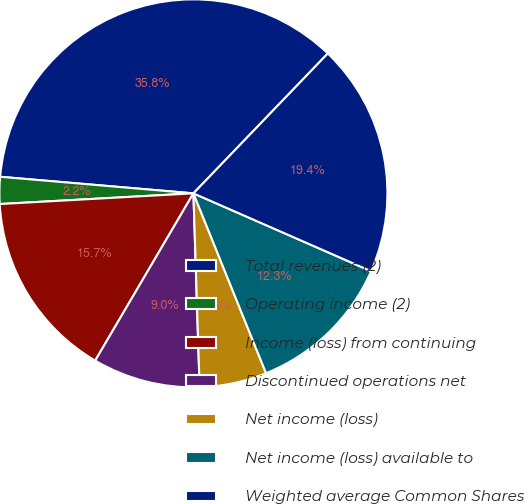<chart> <loc_0><loc_0><loc_500><loc_500><pie_chart><fcel>Total revenues (2)<fcel>Operating income (2)<fcel>Income (loss) from continuing<fcel>Discontinued operations net<fcel>Net income (loss)<fcel>Net income (loss) available to<fcel>Weighted average Common Shares<nl><fcel>35.82%<fcel>2.24%<fcel>15.67%<fcel>8.96%<fcel>5.6%<fcel>12.32%<fcel>19.39%<nl></chart> 